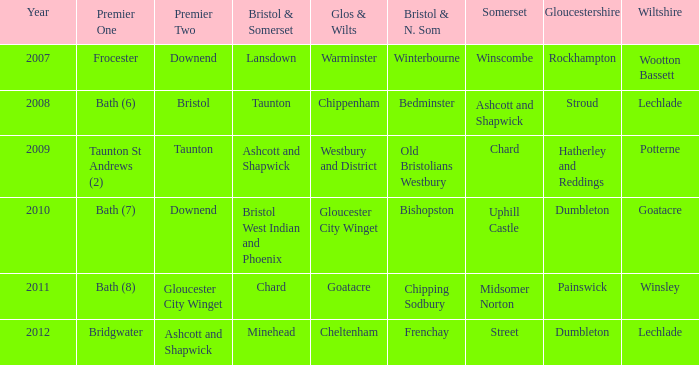What is the 2009 somerset? Chard. 